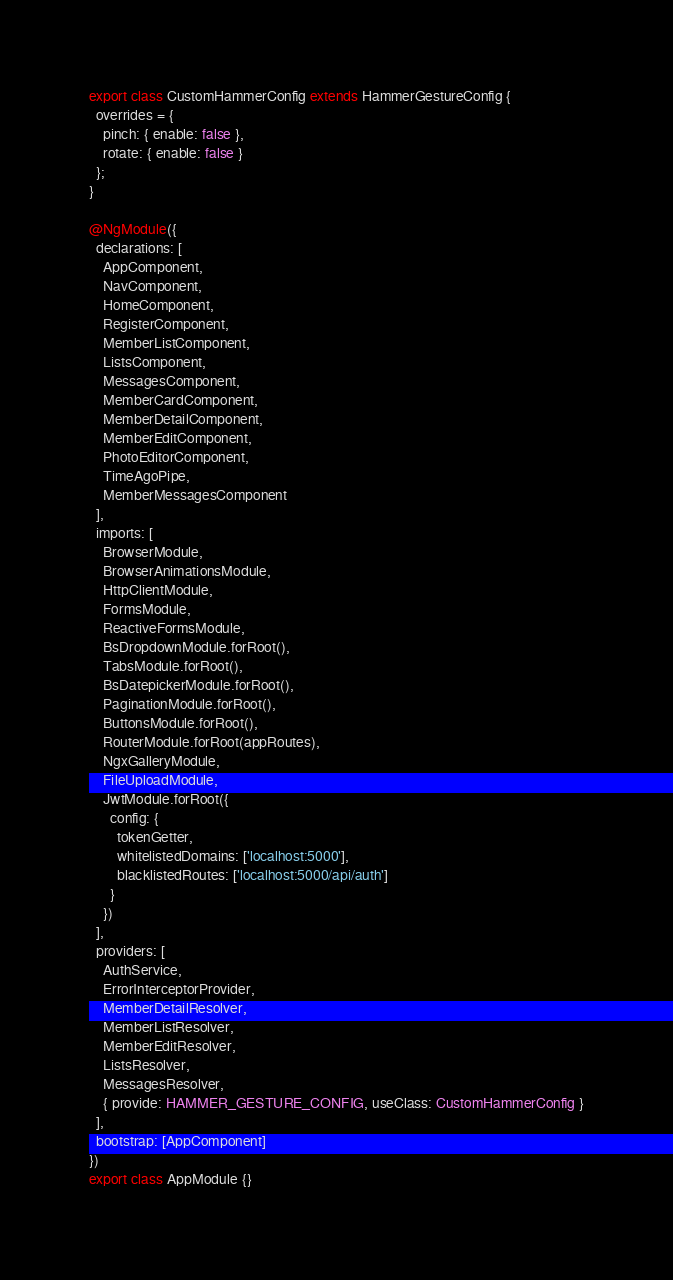<code> <loc_0><loc_0><loc_500><loc_500><_TypeScript_>export class CustomHammerConfig extends HammerGestureConfig {
  overrides = {
    pinch: { enable: false },
    rotate: { enable: false }
  };
}

@NgModule({
  declarations: [
    AppComponent,
    NavComponent,
    HomeComponent,
    RegisterComponent,
    MemberListComponent,
    ListsComponent,
    MessagesComponent,
    MemberCardComponent,
    MemberDetailComponent,
    MemberEditComponent,
    PhotoEditorComponent,
    TimeAgoPipe,
    MemberMessagesComponent
  ],
  imports: [
    BrowserModule,
    BrowserAnimationsModule,
    HttpClientModule,
    FormsModule,
    ReactiveFormsModule,
    BsDropdownModule.forRoot(),
    TabsModule.forRoot(),
    BsDatepickerModule.forRoot(),
    PaginationModule.forRoot(),
    ButtonsModule.forRoot(),
    RouterModule.forRoot(appRoutes),
    NgxGalleryModule,
    FileUploadModule,
    JwtModule.forRoot({
      config: {
        tokenGetter,
        whitelistedDomains: ['localhost:5000'],
        blacklistedRoutes: ['localhost:5000/api/auth']
      }
    })
  ],
  providers: [
    AuthService,
    ErrorInterceptorProvider,
    MemberDetailResolver,
    MemberListResolver,
    MemberEditResolver,
    ListsResolver,
    MessagesResolver,
    { provide: HAMMER_GESTURE_CONFIG, useClass: CustomHammerConfig }
  ],
  bootstrap: [AppComponent]
})
export class AppModule {}
</code> 